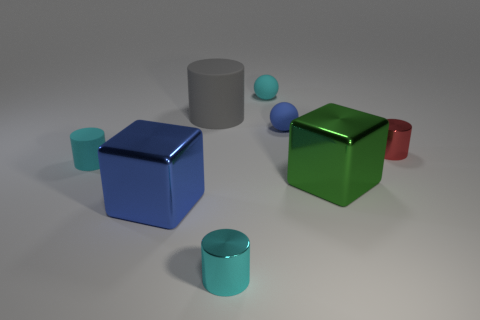Add 2 small blue balls. How many objects exist? 10 Subtract all tiny cylinders. How many cylinders are left? 1 Subtract all blue balls. How many balls are left? 1 Subtract 1 red cylinders. How many objects are left? 7 Subtract 2 blocks. How many blocks are left? 0 Subtract all green cylinders. Subtract all purple blocks. How many cylinders are left? 4 Subtract all blue blocks. How many green spheres are left? 0 Subtract all shiny cylinders. Subtract all tiny cyan objects. How many objects are left? 3 Add 6 red metallic cylinders. How many red metallic cylinders are left? 7 Add 1 small brown objects. How many small brown objects exist? 1 